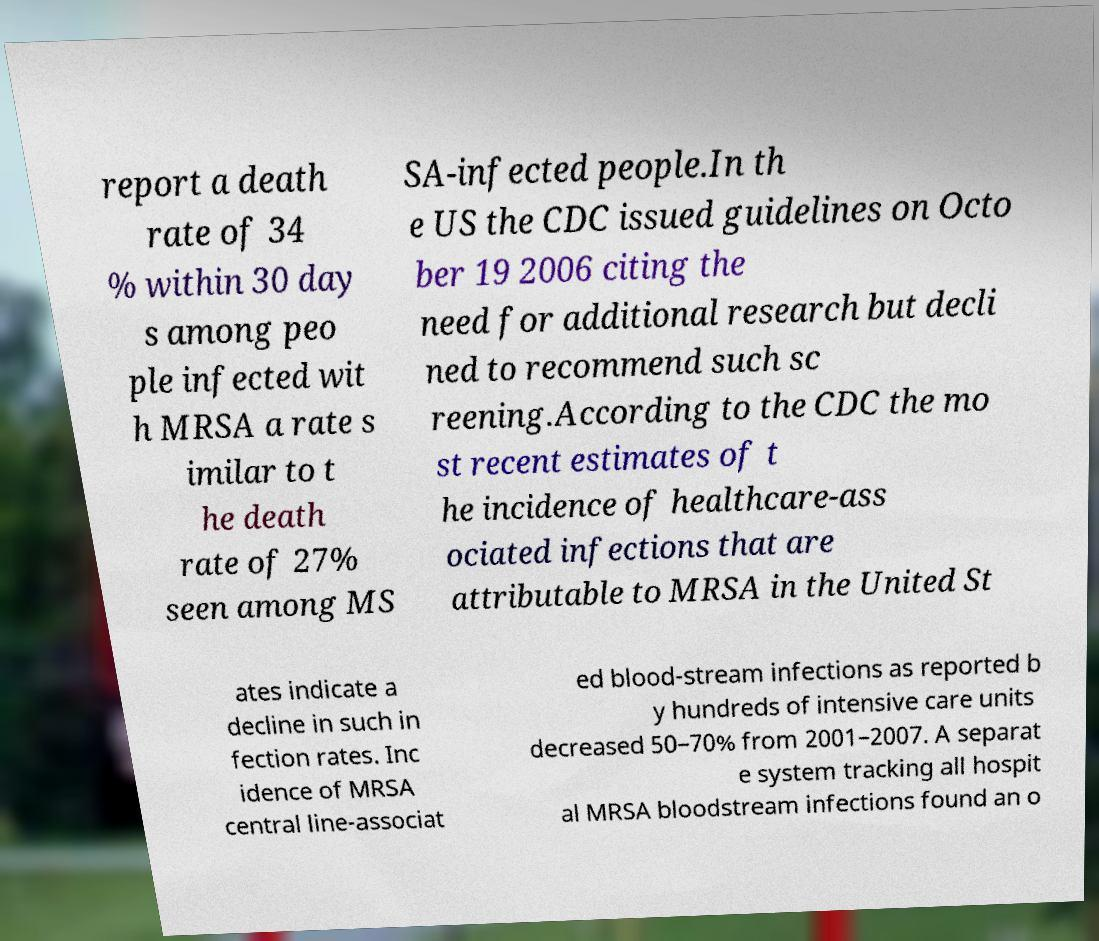Could you extract and type out the text from this image? report a death rate of 34 % within 30 day s among peo ple infected wit h MRSA a rate s imilar to t he death rate of 27% seen among MS SA-infected people.In th e US the CDC issued guidelines on Octo ber 19 2006 citing the need for additional research but decli ned to recommend such sc reening.According to the CDC the mo st recent estimates of t he incidence of healthcare-ass ociated infections that are attributable to MRSA in the United St ates indicate a decline in such in fection rates. Inc idence of MRSA central line-associat ed blood-stream infections as reported b y hundreds of intensive care units decreased 50–70% from 2001–2007. A separat e system tracking all hospit al MRSA bloodstream infections found an o 